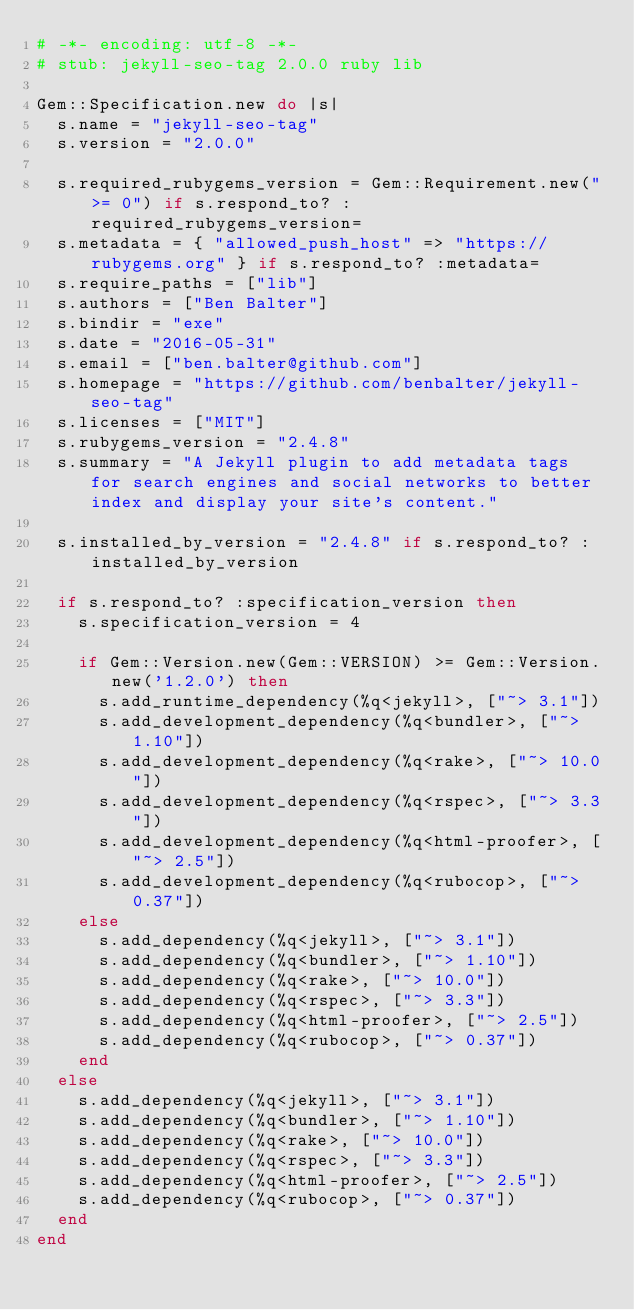<code> <loc_0><loc_0><loc_500><loc_500><_Ruby_># -*- encoding: utf-8 -*-
# stub: jekyll-seo-tag 2.0.0 ruby lib

Gem::Specification.new do |s|
  s.name = "jekyll-seo-tag"
  s.version = "2.0.0"

  s.required_rubygems_version = Gem::Requirement.new(">= 0") if s.respond_to? :required_rubygems_version=
  s.metadata = { "allowed_push_host" => "https://rubygems.org" } if s.respond_to? :metadata=
  s.require_paths = ["lib"]
  s.authors = ["Ben Balter"]
  s.bindir = "exe"
  s.date = "2016-05-31"
  s.email = ["ben.balter@github.com"]
  s.homepage = "https://github.com/benbalter/jekyll-seo-tag"
  s.licenses = ["MIT"]
  s.rubygems_version = "2.4.8"
  s.summary = "A Jekyll plugin to add metadata tags for search engines and social networks to better index and display your site's content."

  s.installed_by_version = "2.4.8" if s.respond_to? :installed_by_version

  if s.respond_to? :specification_version then
    s.specification_version = 4

    if Gem::Version.new(Gem::VERSION) >= Gem::Version.new('1.2.0') then
      s.add_runtime_dependency(%q<jekyll>, ["~> 3.1"])
      s.add_development_dependency(%q<bundler>, ["~> 1.10"])
      s.add_development_dependency(%q<rake>, ["~> 10.0"])
      s.add_development_dependency(%q<rspec>, ["~> 3.3"])
      s.add_development_dependency(%q<html-proofer>, ["~> 2.5"])
      s.add_development_dependency(%q<rubocop>, ["~> 0.37"])
    else
      s.add_dependency(%q<jekyll>, ["~> 3.1"])
      s.add_dependency(%q<bundler>, ["~> 1.10"])
      s.add_dependency(%q<rake>, ["~> 10.0"])
      s.add_dependency(%q<rspec>, ["~> 3.3"])
      s.add_dependency(%q<html-proofer>, ["~> 2.5"])
      s.add_dependency(%q<rubocop>, ["~> 0.37"])
    end
  else
    s.add_dependency(%q<jekyll>, ["~> 3.1"])
    s.add_dependency(%q<bundler>, ["~> 1.10"])
    s.add_dependency(%q<rake>, ["~> 10.0"])
    s.add_dependency(%q<rspec>, ["~> 3.3"])
    s.add_dependency(%q<html-proofer>, ["~> 2.5"])
    s.add_dependency(%q<rubocop>, ["~> 0.37"])
  end
end
</code> 